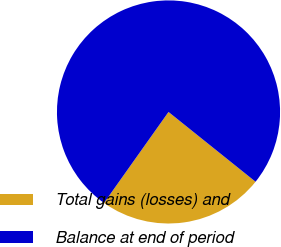<chart> <loc_0><loc_0><loc_500><loc_500><pie_chart><fcel>Total gains (losses) and<fcel>Balance at end of period<nl><fcel>24.06%<fcel>75.94%<nl></chart> 